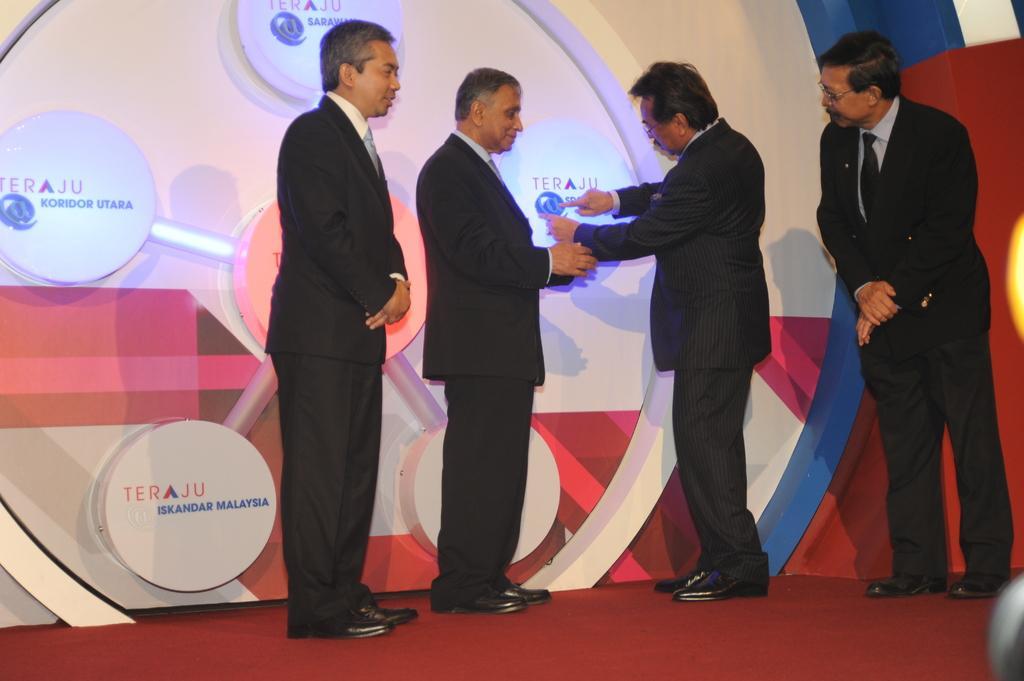Please provide a concise description of this image. In this image there are four people wearing black suit. This person is pointing to a board. In the background there is wall on it there are lights. On the floor there is carpet. 